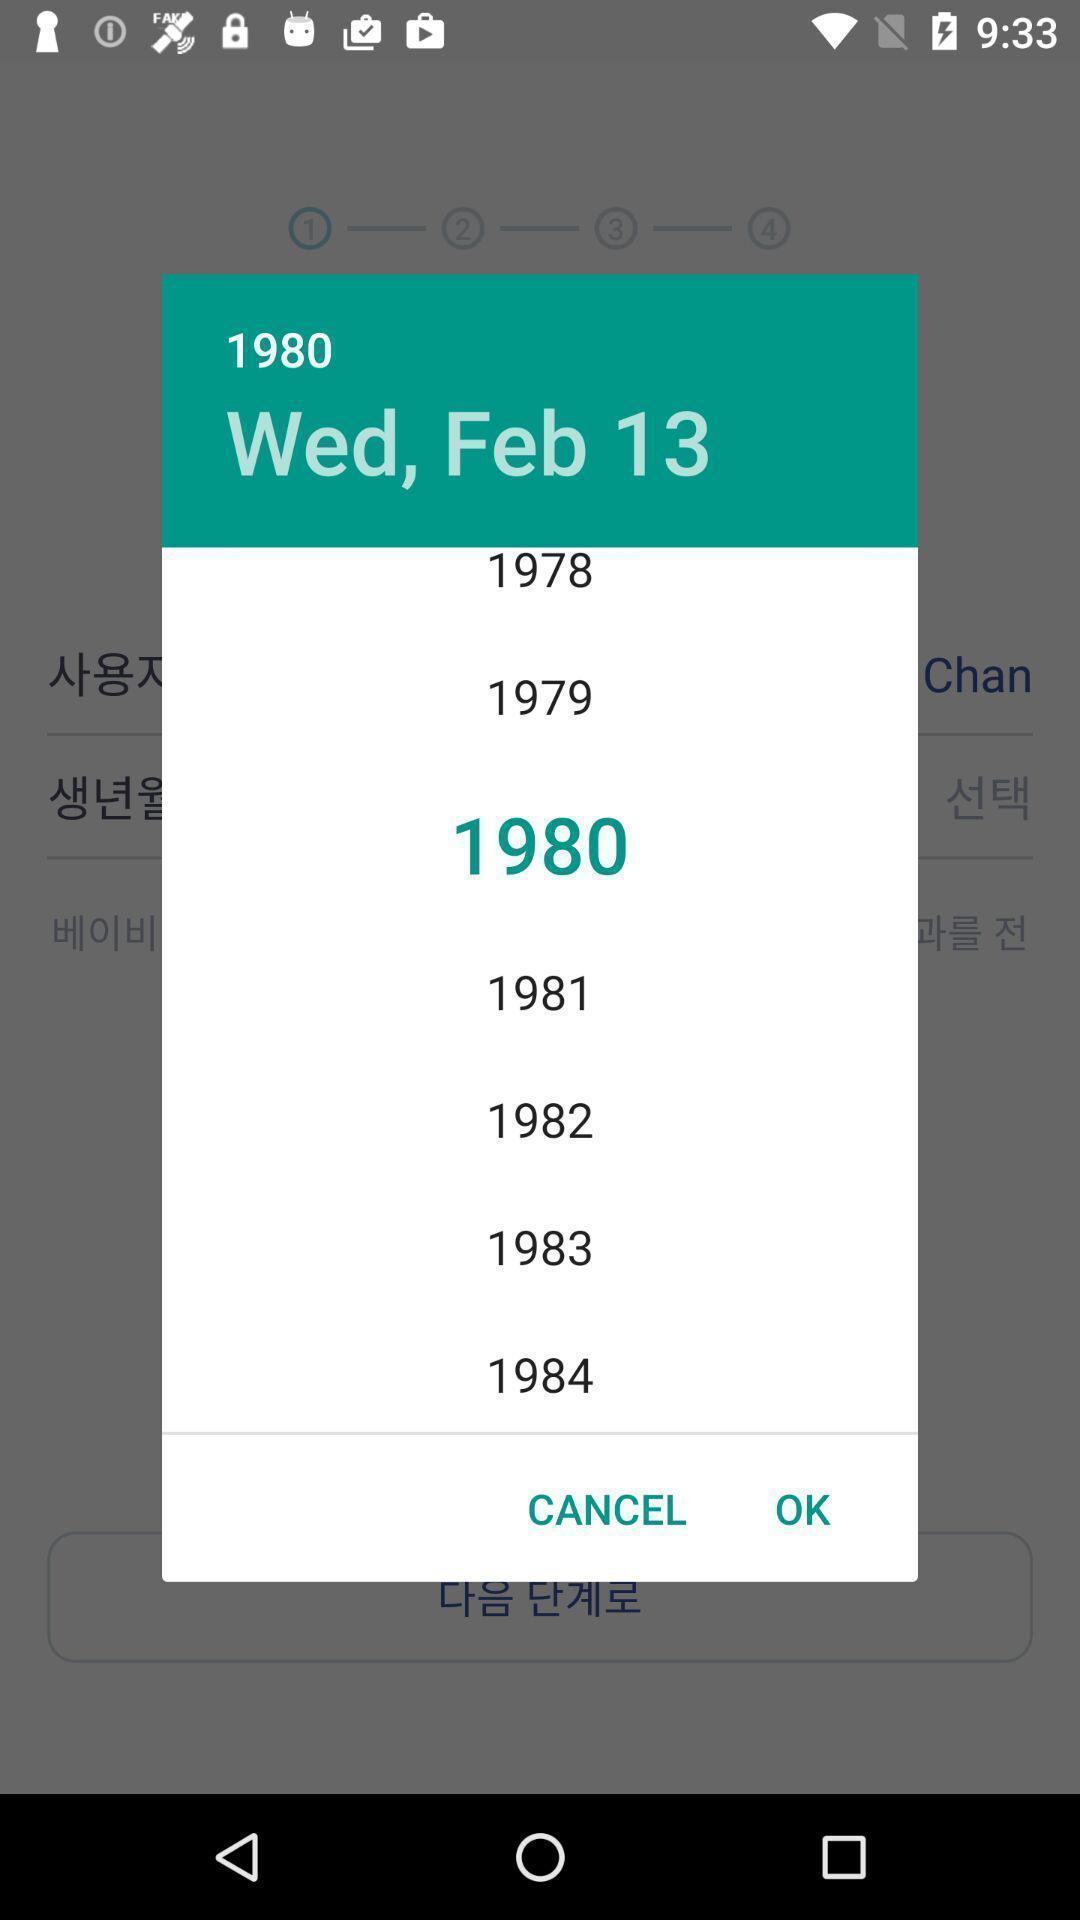Please provide a description for this image. Pop-up shows to select a date. 